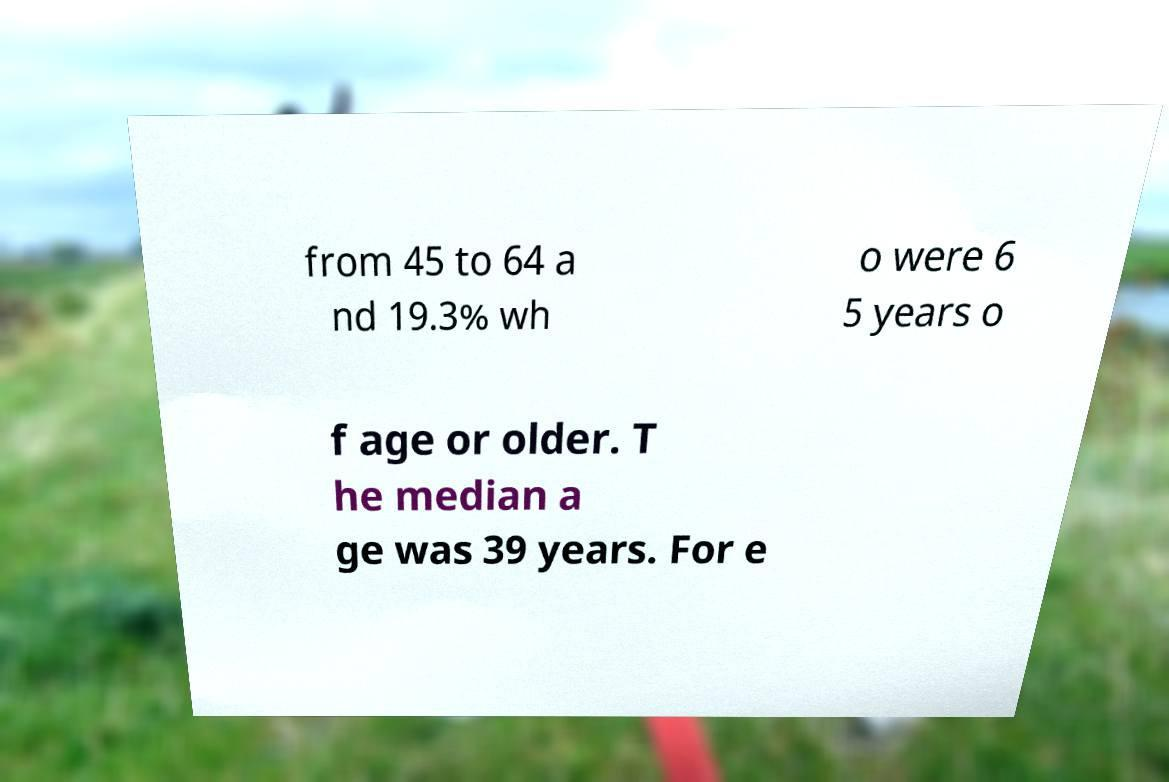Could you extract and type out the text from this image? from 45 to 64 a nd 19.3% wh o were 6 5 years o f age or older. T he median a ge was 39 years. For e 